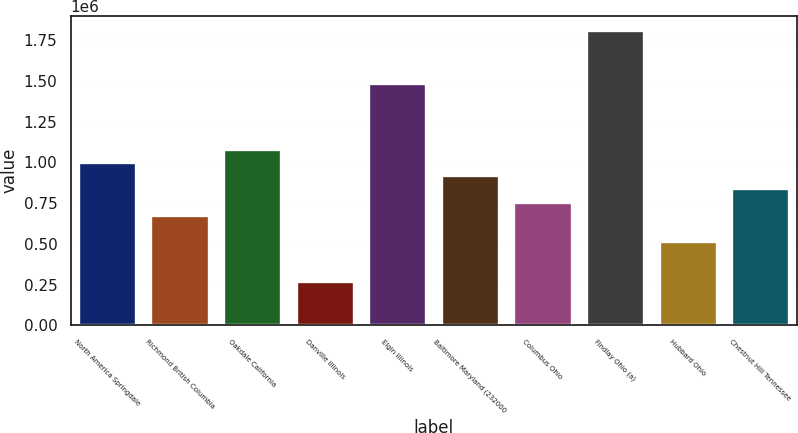<chart> <loc_0><loc_0><loc_500><loc_500><bar_chart><fcel>North America Springdale<fcel>Richmond British Columbia<fcel>Oakdale California<fcel>Danville Illinois<fcel>Elgin Illinois<fcel>Baltimore Maryland (232000<fcel>Columbus Ohio<fcel>Findlay Ohio (a)<fcel>Hubbard Ohio<fcel>Chestnut Hill Tennessee<nl><fcel>1.0016e+06<fcel>678400<fcel>1.0824e+06<fcel>274400<fcel>1.4864e+06<fcel>920800<fcel>759200<fcel>1.8096e+06<fcel>516800<fcel>840000<nl></chart> 